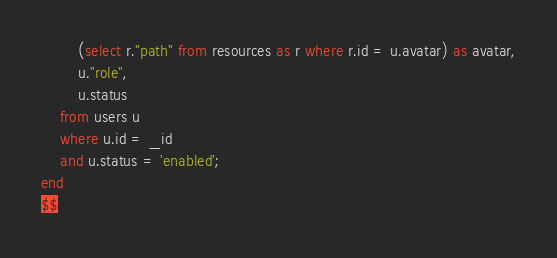Convert code to text. <code><loc_0><loc_0><loc_500><loc_500><_SQL_>		(select r."path" from resources as r where r.id = u.avatar) as avatar,
		u."role",
		u.status
	from users u
	where u.id = _id
	and u.status = 'enabled';
end
$$
</code> 